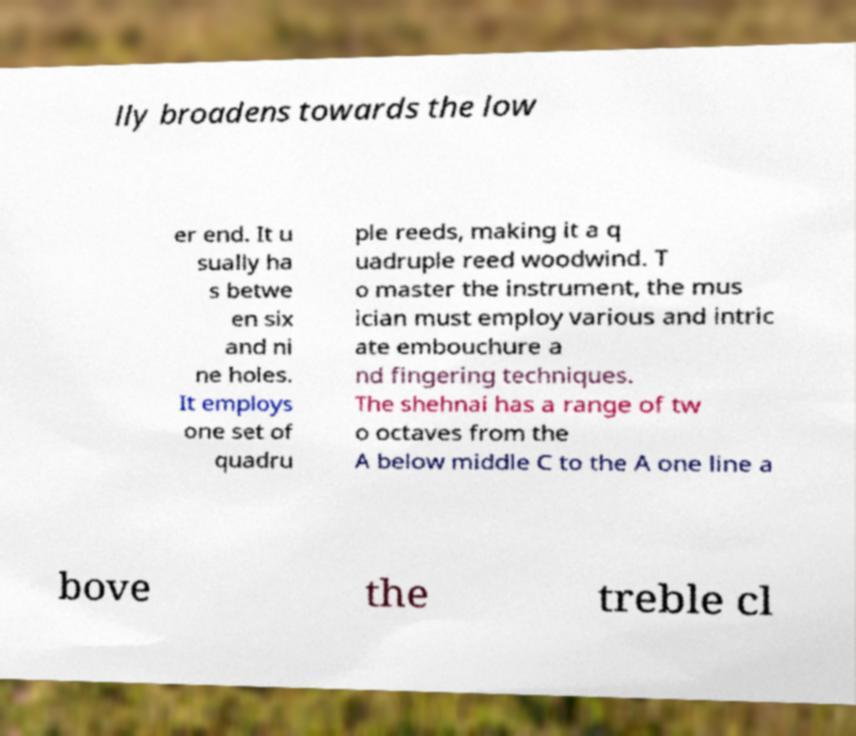Please identify and transcribe the text found in this image. lly broadens towards the low er end. It u sually ha s betwe en six and ni ne holes. It employs one set of quadru ple reeds, making it a q uadruple reed woodwind. T o master the instrument, the mus ician must employ various and intric ate embouchure a nd fingering techniques. The shehnai has a range of tw o octaves from the A below middle C to the A one line a bove the treble cl 